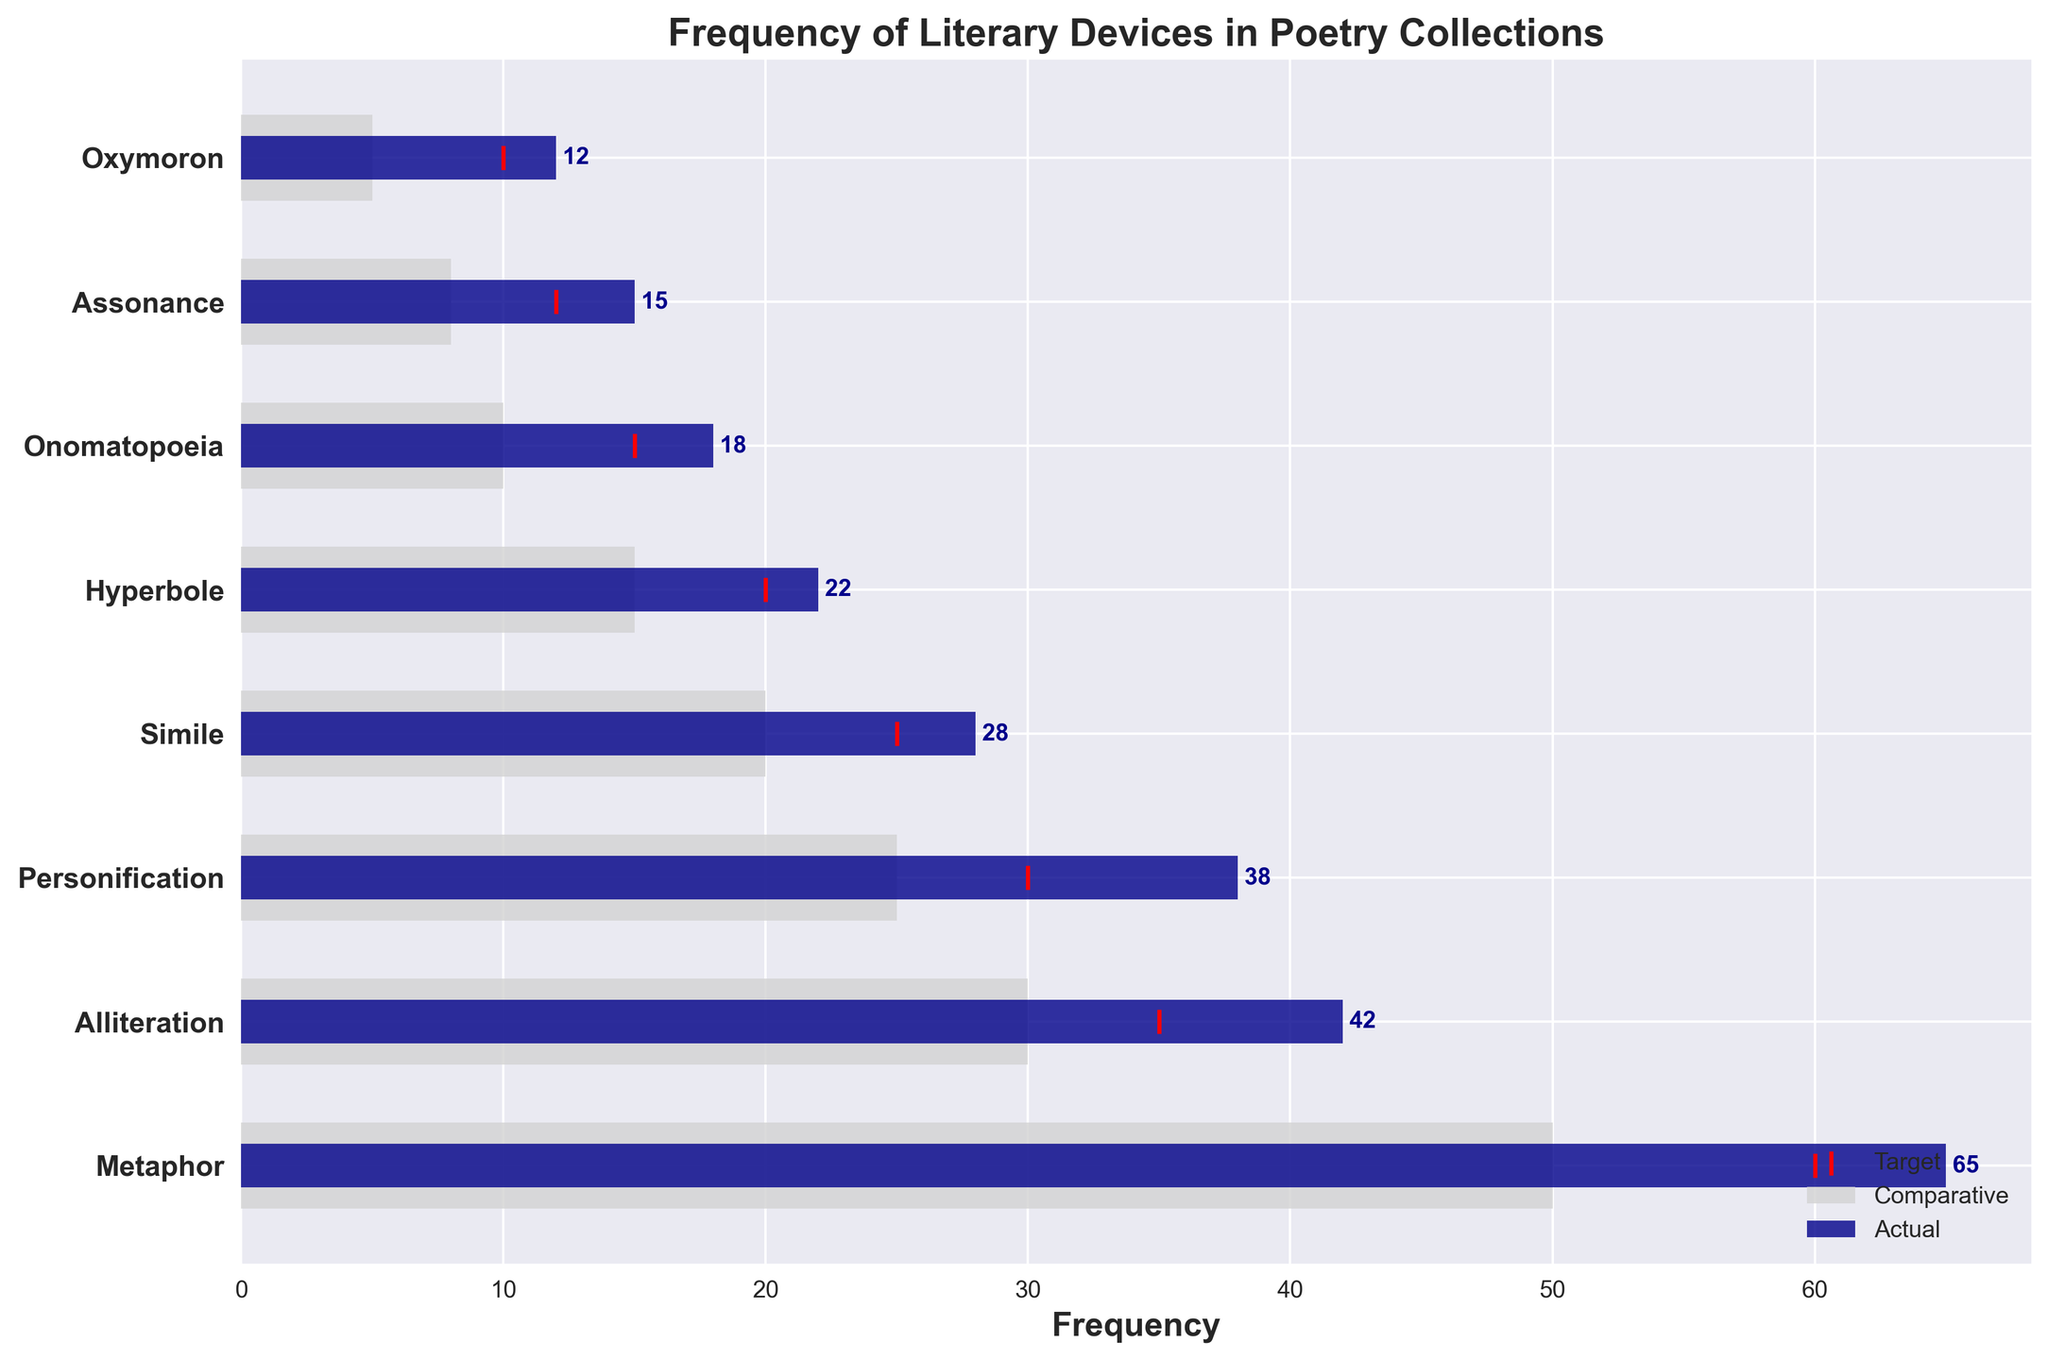What is the title of the chart? The title of the chart is written at the top of the figure.
Answer: Frequency of Literary Devices in Poetry Collections What is the frequency of Alliteration in the poetry collections? The frequency of Alliteration is given by the dark blue bar corresponding to 'Alliteration'.
Answer: 42 Which literary device has the highest actual frequency in the poetry collections? By comparing the lengths of the dark blue bars for each device, the longest bar represents the highest frequency.
Answer: Metaphor What is the difference between the actual and target frequency for Onomatopoeia? The actual frequency for Onomatopoeia is 18 and the target frequency is 15. The difference is calculated by subtracting 15 from 18.
Answer: 3 How does the actual frequency of Personification compare to its comparative frequency? The actual frequency for Personification is given by the length of the dark blue bar for 'Personification' and the comparative frequency by the light grey bar.
Answer: The actual frequency is higher Sum the actual frequencies of Simile and Hyperbole. Add the actual frequencies of Simile (28) and Hyperbole (22).
Answer: 50 What is the average target frequency of the literary devices? Sum all the target frequencies (60 + 35 + 30 + 25 + 20 + 15 + 12 + 10) and divide by the number of devices (8). (60 + 35 + 30 + 25 + 20 + 15 + 12 + 10 = 207; 207 / 8 = 25.875)
Answer: 25.875 Which literary device exceeds its target frequency by the most? Compare the difference between the actual and target frequencies for each device and find the largest positive difference. Metaphor exceeds its target (65 - 60) by 5, the highest difference.
Answer: Metaphor What is the frequency of Assonance according to the comparative data? Check the light grey bar for Assonance to find its comparative frequency.
Answer: 8 How many literary devices meet or exceed their target frequencies in the actual data? Count the number of devices where the dark blue bar is equal to or longer than the red marker (Target). Metaphor, Alliteration, Personification, Simile, Hyperbole, and Onomatopoeia meet or exceed their targets.
Answer: 6 